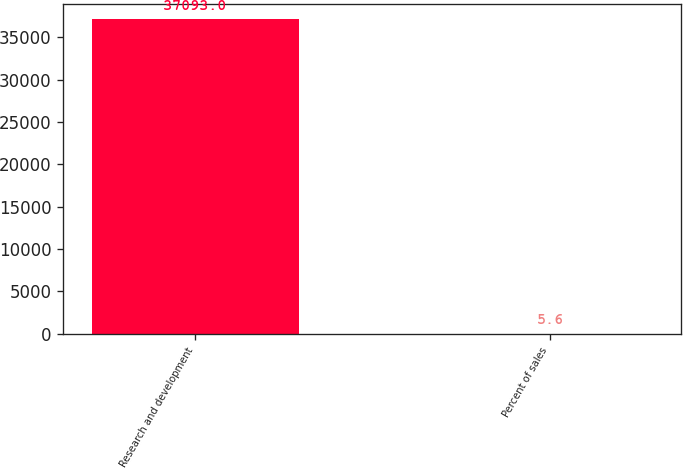Convert chart. <chart><loc_0><loc_0><loc_500><loc_500><bar_chart><fcel>Research and development<fcel>Percent of sales<nl><fcel>37093<fcel>5.6<nl></chart> 